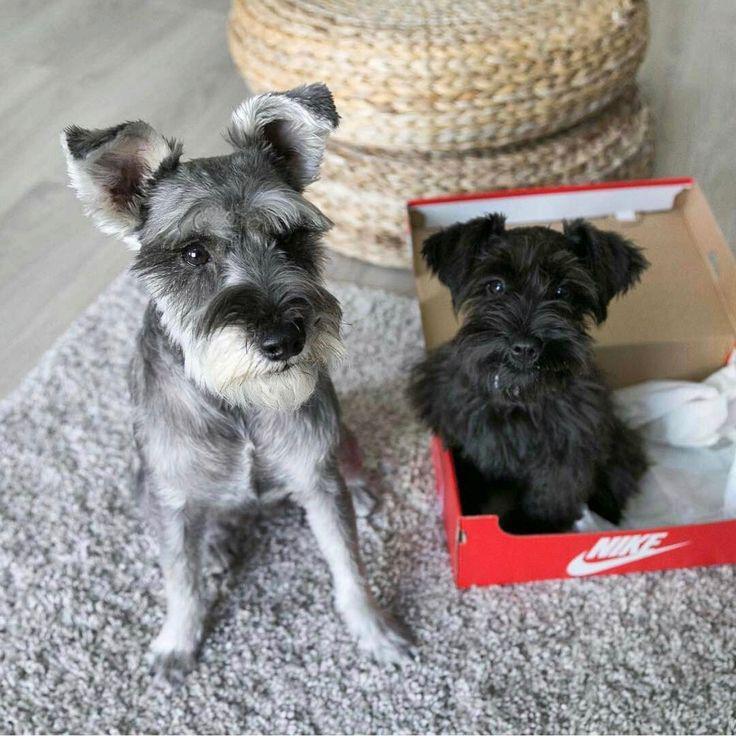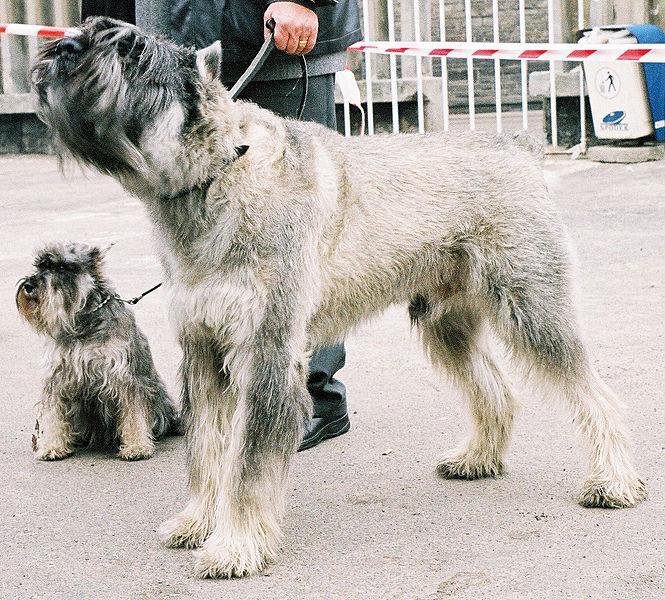The first image is the image on the left, the second image is the image on the right. Analyze the images presented: Is the assertion "There are exactly two dogs." valid? Answer yes or no. No. The first image is the image on the left, the second image is the image on the right. For the images shown, is this caption "Each image shows one forward-facing, non-standing schnauzer with a grayish coat and lighter hair on its muzzle." true? Answer yes or no. No. 